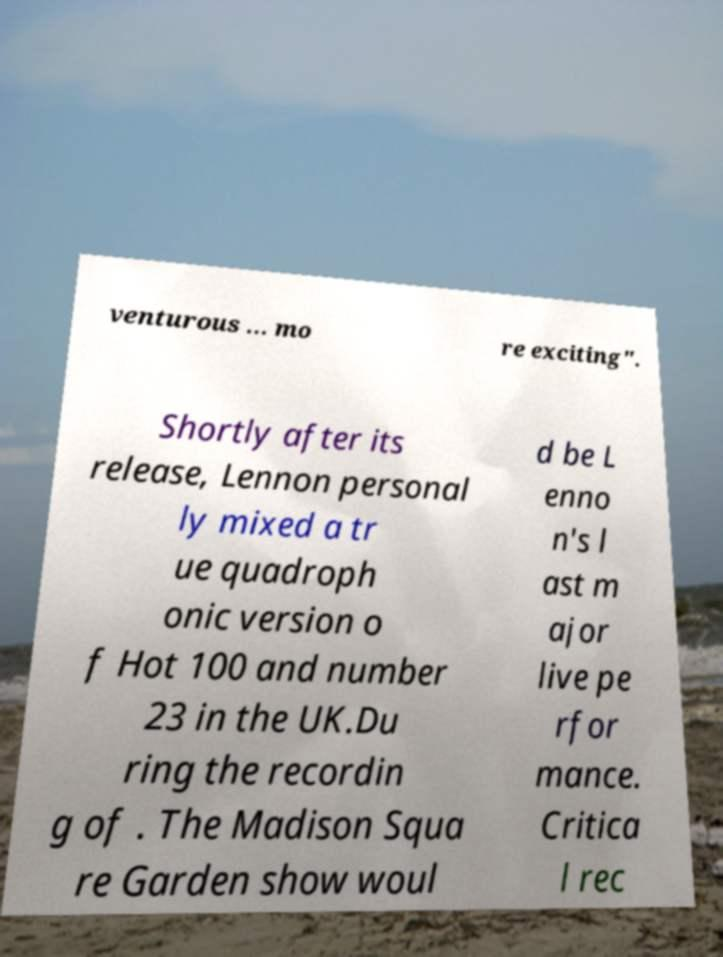Could you extract and type out the text from this image? venturous … mo re exciting". Shortly after its release, Lennon personal ly mixed a tr ue quadroph onic version o f Hot 100 and number 23 in the UK.Du ring the recordin g of . The Madison Squa re Garden show woul d be L enno n's l ast m ajor live pe rfor mance. Critica l rec 